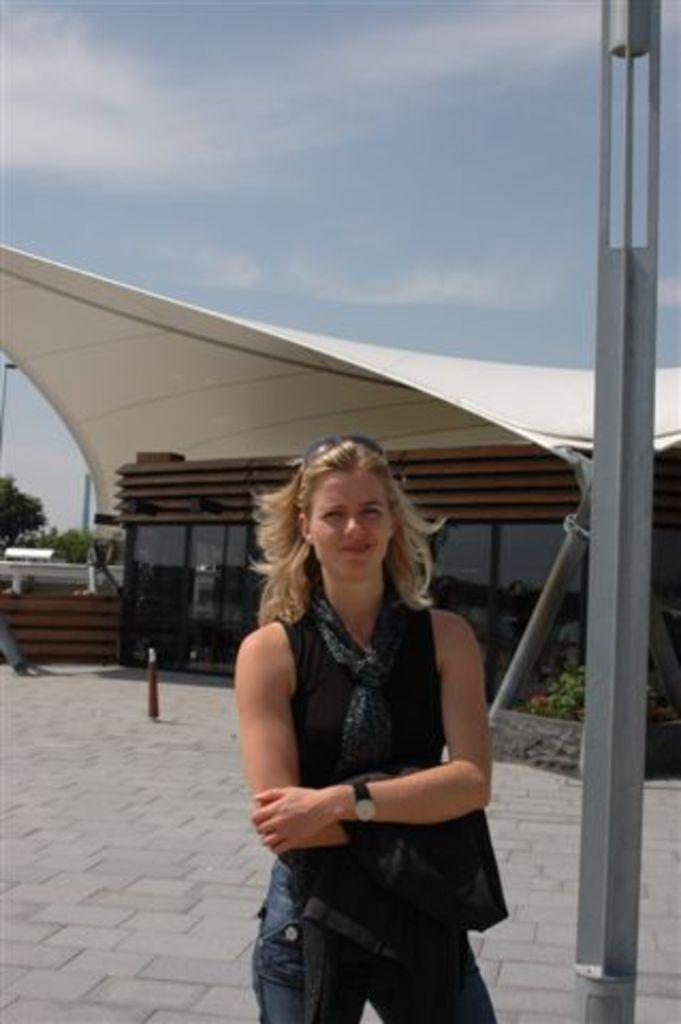Describe this image in one or two sentences. In the foreground of the picture there is a woman standing. On the right there is a pole. In the background there are trees, plant and a building. Sky is sunny. 